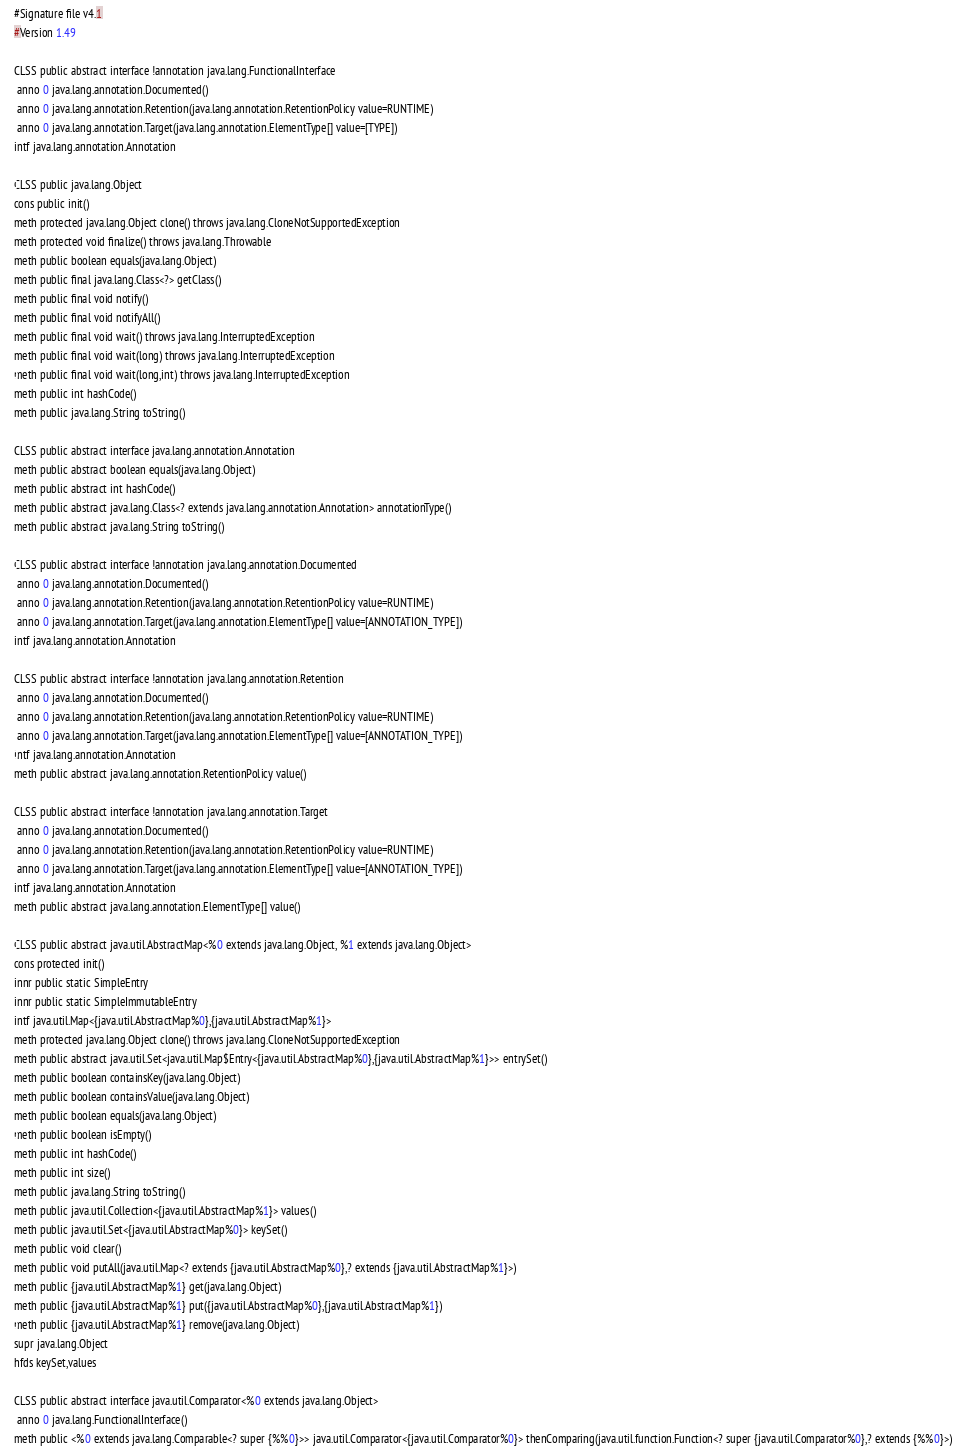Convert code to text. <code><loc_0><loc_0><loc_500><loc_500><_SML_>#Signature file v4.1
#Version 1.49

CLSS public abstract interface !annotation java.lang.FunctionalInterface
 anno 0 java.lang.annotation.Documented()
 anno 0 java.lang.annotation.Retention(java.lang.annotation.RetentionPolicy value=RUNTIME)
 anno 0 java.lang.annotation.Target(java.lang.annotation.ElementType[] value=[TYPE])
intf java.lang.annotation.Annotation

CLSS public java.lang.Object
cons public init()
meth protected java.lang.Object clone() throws java.lang.CloneNotSupportedException
meth protected void finalize() throws java.lang.Throwable
meth public boolean equals(java.lang.Object)
meth public final java.lang.Class<?> getClass()
meth public final void notify()
meth public final void notifyAll()
meth public final void wait() throws java.lang.InterruptedException
meth public final void wait(long) throws java.lang.InterruptedException
meth public final void wait(long,int) throws java.lang.InterruptedException
meth public int hashCode()
meth public java.lang.String toString()

CLSS public abstract interface java.lang.annotation.Annotation
meth public abstract boolean equals(java.lang.Object)
meth public abstract int hashCode()
meth public abstract java.lang.Class<? extends java.lang.annotation.Annotation> annotationType()
meth public abstract java.lang.String toString()

CLSS public abstract interface !annotation java.lang.annotation.Documented
 anno 0 java.lang.annotation.Documented()
 anno 0 java.lang.annotation.Retention(java.lang.annotation.RetentionPolicy value=RUNTIME)
 anno 0 java.lang.annotation.Target(java.lang.annotation.ElementType[] value=[ANNOTATION_TYPE])
intf java.lang.annotation.Annotation

CLSS public abstract interface !annotation java.lang.annotation.Retention
 anno 0 java.lang.annotation.Documented()
 anno 0 java.lang.annotation.Retention(java.lang.annotation.RetentionPolicy value=RUNTIME)
 anno 0 java.lang.annotation.Target(java.lang.annotation.ElementType[] value=[ANNOTATION_TYPE])
intf java.lang.annotation.Annotation
meth public abstract java.lang.annotation.RetentionPolicy value()

CLSS public abstract interface !annotation java.lang.annotation.Target
 anno 0 java.lang.annotation.Documented()
 anno 0 java.lang.annotation.Retention(java.lang.annotation.RetentionPolicy value=RUNTIME)
 anno 0 java.lang.annotation.Target(java.lang.annotation.ElementType[] value=[ANNOTATION_TYPE])
intf java.lang.annotation.Annotation
meth public abstract java.lang.annotation.ElementType[] value()

CLSS public abstract java.util.AbstractMap<%0 extends java.lang.Object, %1 extends java.lang.Object>
cons protected init()
innr public static SimpleEntry
innr public static SimpleImmutableEntry
intf java.util.Map<{java.util.AbstractMap%0},{java.util.AbstractMap%1}>
meth protected java.lang.Object clone() throws java.lang.CloneNotSupportedException
meth public abstract java.util.Set<java.util.Map$Entry<{java.util.AbstractMap%0},{java.util.AbstractMap%1}>> entrySet()
meth public boolean containsKey(java.lang.Object)
meth public boolean containsValue(java.lang.Object)
meth public boolean equals(java.lang.Object)
meth public boolean isEmpty()
meth public int hashCode()
meth public int size()
meth public java.lang.String toString()
meth public java.util.Collection<{java.util.AbstractMap%1}> values()
meth public java.util.Set<{java.util.AbstractMap%0}> keySet()
meth public void clear()
meth public void putAll(java.util.Map<? extends {java.util.AbstractMap%0},? extends {java.util.AbstractMap%1}>)
meth public {java.util.AbstractMap%1} get(java.lang.Object)
meth public {java.util.AbstractMap%1} put({java.util.AbstractMap%0},{java.util.AbstractMap%1})
meth public {java.util.AbstractMap%1} remove(java.lang.Object)
supr java.lang.Object
hfds keySet,values

CLSS public abstract interface java.util.Comparator<%0 extends java.lang.Object>
 anno 0 java.lang.FunctionalInterface()
meth public <%0 extends java.lang.Comparable<? super {%%0}>> java.util.Comparator<{java.util.Comparator%0}> thenComparing(java.util.function.Function<? super {java.util.Comparator%0},? extends {%%0}>)</code> 